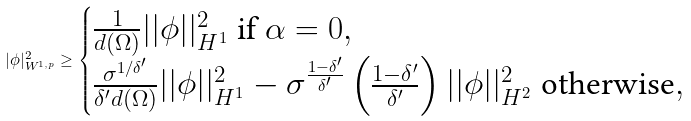Convert formula to latex. <formula><loc_0><loc_0><loc_500><loc_500>| \phi | ^ { 2 } _ { W ^ { 1 , p } } \geq \begin{cases} \frac { 1 } { d ( \Omega ) } | | \phi | | ^ { 2 } _ { H ^ { 1 } } \text { if } \alpha = 0 , \\ \frac { \sigma ^ { 1 / \delta ^ { \prime } } } { \delta ^ { \prime } d ( \Omega ) } | | \phi | | ^ { 2 } _ { H ^ { 1 } } - \sigma ^ { \frac { 1 - \delta ^ { \prime } } { \delta ^ { \prime } } } \left ( \frac { 1 - \delta ^ { \prime } } { \delta ^ { \prime } } \right ) | | \phi | | ^ { 2 } _ { H ^ { 2 } } \text { otherwise} , \end{cases}</formula> 